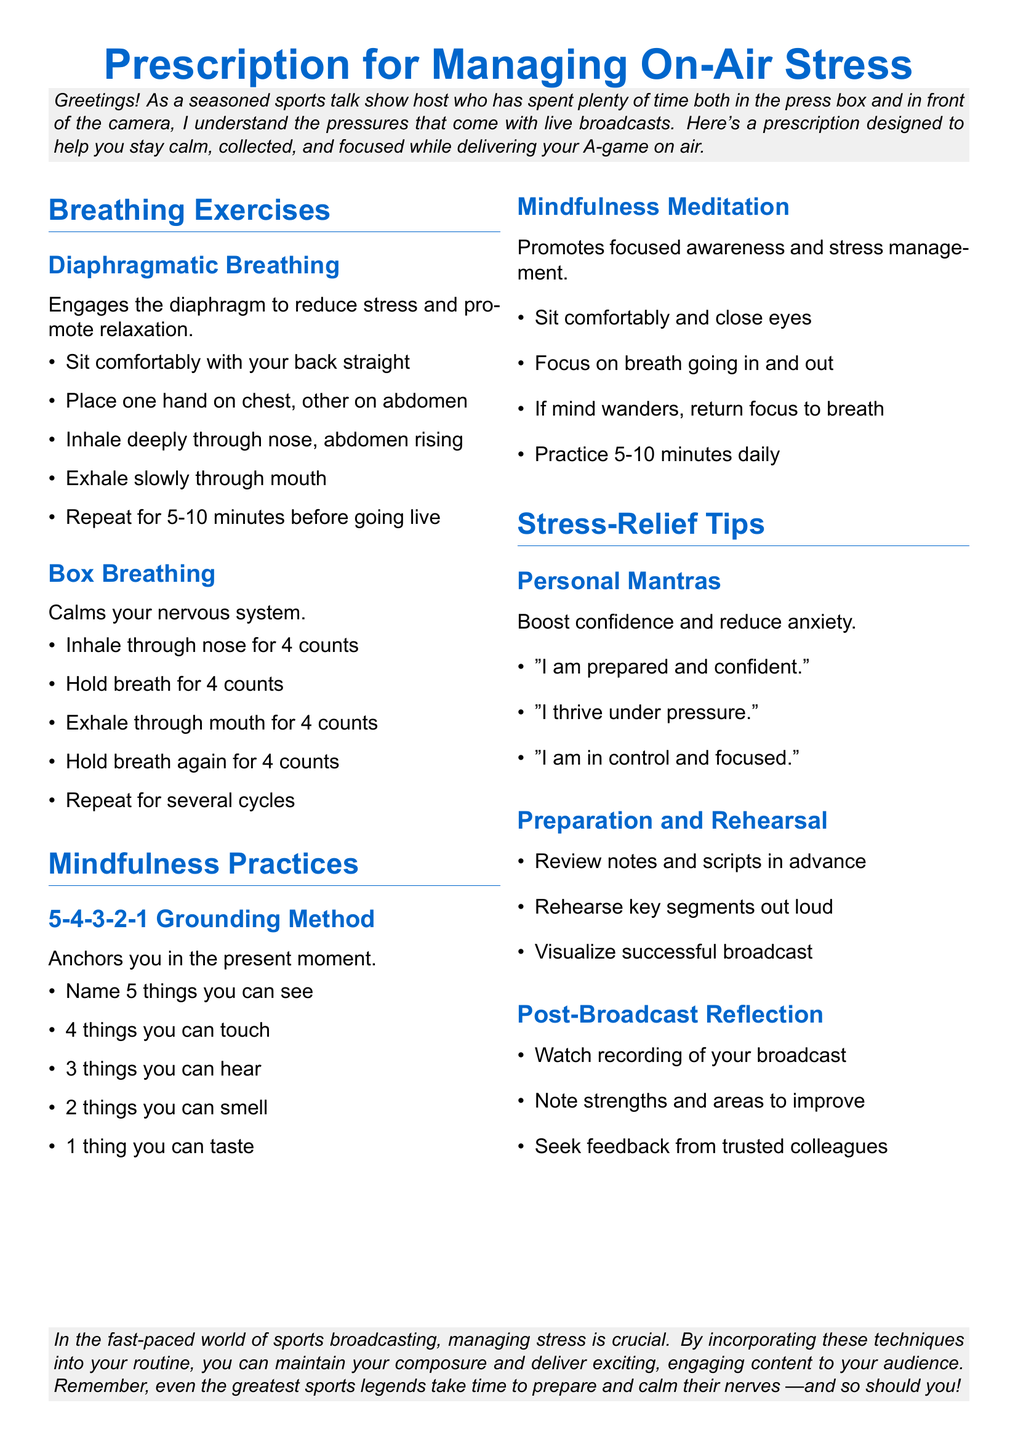What are the two types of breathing exercises mentioned? The document lists two breathing exercises: Diaphragmatic Breathing and Box Breathing.
Answer: Diaphragmatic Breathing, Box Breathing How long should you practice mindfulness meditation daily? The document specifies that mindfulness meditation should be practiced for 5-10 minutes daily.
Answer: 5-10 minutes What is the purpose of personal mantras according to the document? The document states that personal mantras are used to boost confidence and reduce anxiety.
Answer: Boost confidence and reduce anxiety What technique involves naming sensory experiences? The document describes the 5-4-3-2-1 Grounding Method, which involves naming sensory experiences.
Answer: 5-4-3-2-1 Grounding Method What should you do during post-broadcast reflection? The document advises watching the recording of your broadcast and noting strengths and areas to improve.
Answer: Watch recording and note strengths and areas to improve Which breathing technique helps calm the nervous system? The document indicates that Box Breathing is the technique that calms the nervous system.
Answer: Box Breathing What is one recommended preparation technique before going live? The document suggests reviewing notes and scripts in advance as a preparation technique before going live.
Answer: Review notes and scripts in advance How can you visualize a successful broadcast? The document mentions visualizing a successful broadcast as part of preparation and rehearsal.
Answer: Visualize successful broadcast 